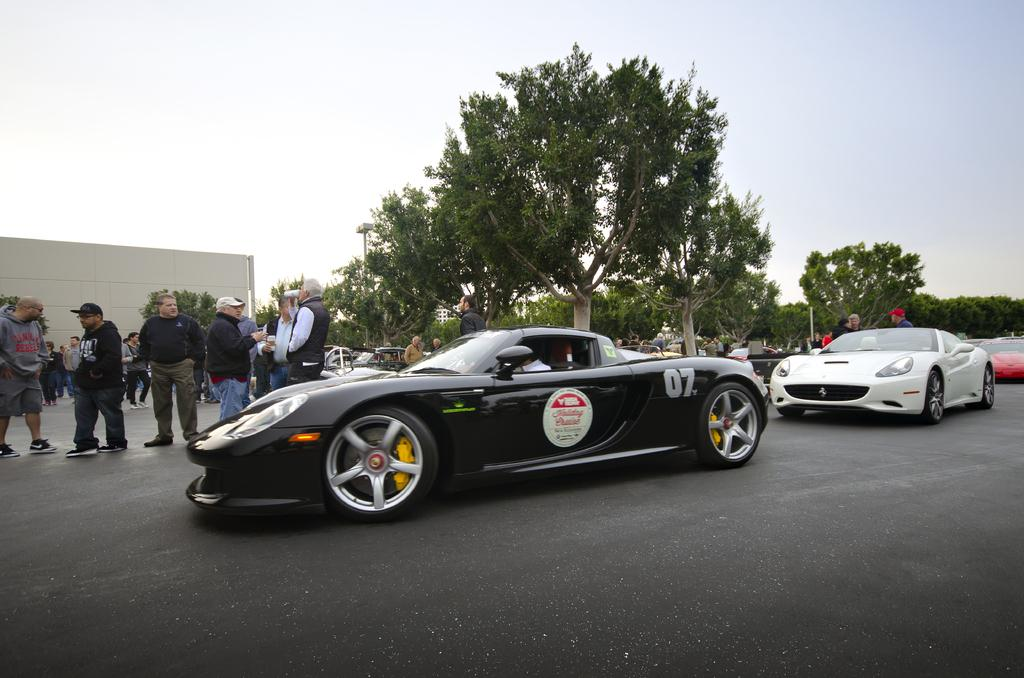What is happening on the road in the image? There are vehicles on the road in the image. What else can be seen near the vehicles? There is a group of people beside the vehicles, and trees are present near the vehicles. What can be seen in the background of the image? There are poles and a building visible in the background of the image. What type of crime is being committed by the maid in the image? There is no maid or crime present in the image. What are the people talking about in the image? The image does not show or indicate any conversation or topic being discussed by the people. 